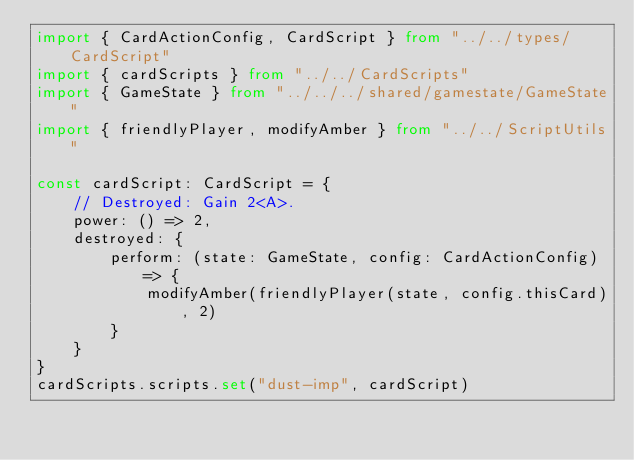<code> <loc_0><loc_0><loc_500><loc_500><_TypeScript_>import { CardActionConfig, CardScript } from "../../types/CardScript"
import { cardScripts } from "../../CardScripts"
import { GameState } from "../../../shared/gamestate/GameState"
import { friendlyPlayer, modifyAmber } from "../../ScriptUtils"

const cardScript: CardScript = {
    // Destroyed: Gain 2<A>.
    power: () => 2,
    destroyed: {
        perform: (state: GameState, config: CardActionConfig) => {
            modifyAmber(friendlyPlayer(state, config.thisCard), 2)
        }
    }
}
cardScripts.scripts.set("dust-imp", cardScript)</code> 